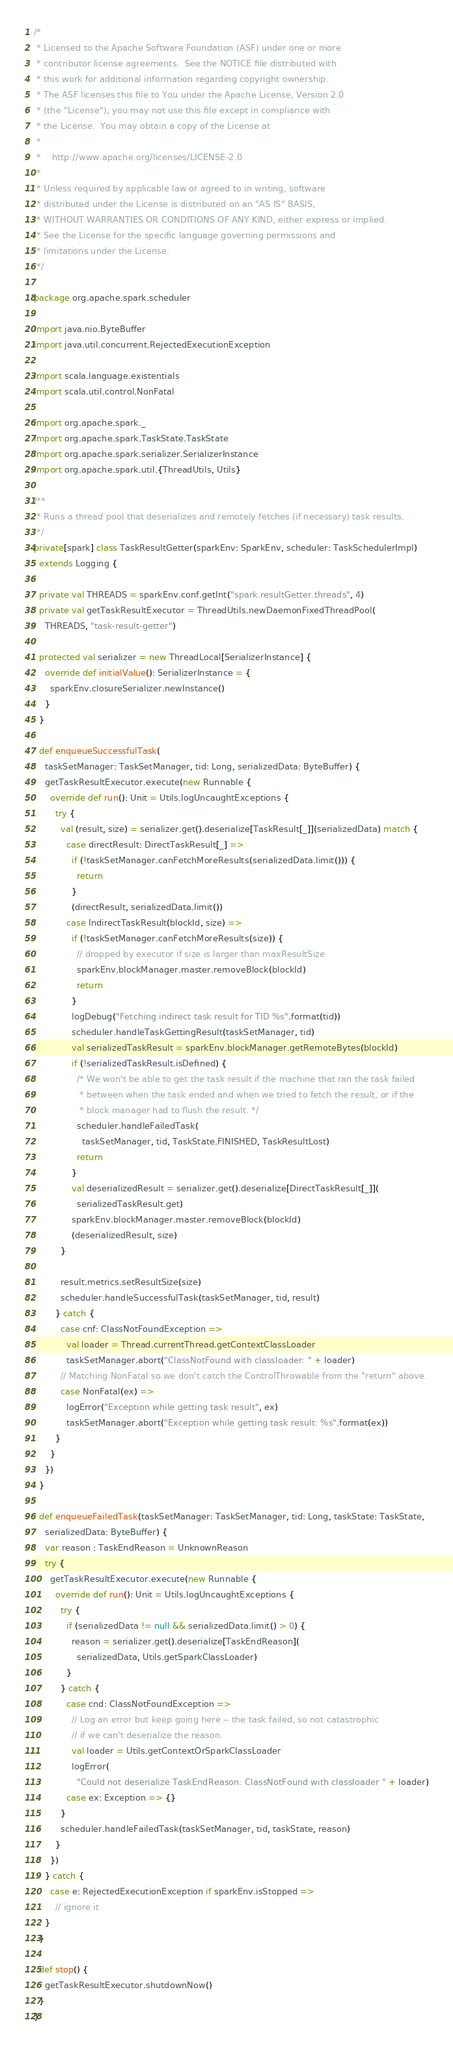Convert code to text. <code><loc_0><loc_0><loc_500><loc_500><_Scala_>/*
 * Licensed to the Apache Software Foundation (ASF) under one or more
 * contributor license agreements.  See the NOTICE file distributed with
 * this work for additional information regarding copyright ownership.
 * The ASF licenses this file to You under the Apache License, Version 2.0
 * (the "License"); you may not use this file except in compliance with
 * the License.  You may obtain a copy of the License at
 *
 *    http://www.apache.org/licenses/LICENSE-2.0
 *
 * Unless required by applicable law or agreed to in writing, software
 * distributed under the License is distributed on an "AS IS" BASIS,
 * WITHOUT WARRANTIES OR CONDITIONS OF ANY KIND, either express or implied.
 * See the License for the specific language governing permissions and
 * limitations under the License.
 */

package org.apache.spark.scheduler

import java.nio.ByteBuffer
import java.util.concurrent.RejectedExecutionException

import scala.language.existentials
import scala.util.control.NonFatal

import org.apache.spark._
import org.apache.spark.TaskState.TaskState
import org.apache.spark.serializer.SerializerInstance
import org.apache.spark.util.{ThreadUtils, Utils}

/**
 * Runs a thread pool that deserializes and remotely fetches (if necessary) task results.
 */
private[spark] class TaskResultGetter(sparkEnv: SparkEnv, scheduler: TaskSchedulerImpl)
  extends Logging {

  private val THREADS = sparkEnv.conf.getInt("spark.resultGetter.threads", 4)
  private val getTaskResultExecutor = ThreadUtils.newDaemonFixedThreadPool(
    THREADS, "task-result-getter")

  protected val serializer = new ThreadLocal[SerializerInstance] {
    override def initialValue(): SerializerInstance = {
      sparkEnv.closureSerializer.newInstance()
    }
  }

  def enqueueSuccessfulTask(
    taskSetManager: TaskSetManager, tid: Long, serializedData: ByteBuffer) {
    getTaskResultExecutor.execute(new Runnable {
      override def run(): Unit = Utils.logUncaughtExceptions {
        try {
          val (result, size) = serializer.get().deserialize[TaskResult[_]](serializedData) match {
            case directResult: DirectTaskResult[_] =>
              if (!taskSetManager.canFetchMoreResults(serializedData.limit())) {
                return
              }
              (directResult, serializedData.limit())
            case IndirectTaskResult(blockId, size) =>
              if (!taskSetManager.canFetchMoreResults(size)) {
                // dropped by executor if size is larger than maxResultSize
                sparkEnv.blockManager.master.removeBlock(blockId)
                return
              }
              logDebug("Fetching indirect task result for TID %s".format(tid))
              scheduler.handleTaskGettingResult(taskSetManager, tid)
              val serializedTaskResult = sparkEnv.blockManager.getRemoteBytes(blockId)
              if (!serializedTaskResult.isDefined) {
                /* We won't be able to get the task result if the machine that ran the task failed
                 * between when the task ended and when we tried to fetch the result, or if the
                 * block manager had to flush the result. */
                scheduler.handleFailedTask(
                  taskSetManager, tid, TaskState.FINISHED, TaskResultLost)
                return
              }
              val deserializedResult = serializer.get().deserialize[DirectTaskResult[_]](
                serializedTaskResult.get)
              sparkEnv.blockManager.master.removeBlock(blockId)
              (deserializedResult, size)
          }

          result.metrics.setResultSize(size)
          scheduler.handleSuccessfulTask(taskSetManager, tid, result)
        } catch {
          case cnf: ClassNotFoundException =>
            val loader = Thread.currentThread.getContextClassLoader
            taskSetManager.abort("ClassNotFound with classloader: " + loader)
          // Matching NonFatal so we don't catch the ControlThrowable from the "return" above.
          case NonFatal(ex) =>
            logError("Exception while getting task result", ex)
            taskSetManager.abort("Exception while getting task result: %s".format(ex))
        }
      }
    })
  }

  def enqueueFailedTask(taskSetManager: TaskSetManager, tid: Long, taskState: TaskState,
    serializedData: ByteBuffer) {
    var reason : TaskEndReason = UnknownReason
    try {
      getTaskResultExecutor.execute(new Runnable {
        override def run(): Unit = Utils.logUncaughtExceptions {
          try {
            if (serializedData != null && serializedData.limit() > 0) {
              reason = serializer.get().deserialize[TaskEndReason](
                serializedData, Utils.getSparkClassLoader)
            }
          } catch {
            case cnd: ClassNotFoundException =>
              // Log an error but keep going here -- the task failed, so not catastrophic
              // if we can't deserialize the reason.
              val loader = Utils.getContextOrSparkClassLoader
              logError(
                "Could not deserialize TaskEndReason: ClassNotFound with classloader " + loader)
            case ex: Exception => {}
          }
          scheduler.handleFailedTask(taskSetManager, tid, taskState, reason)
        }
      })
    } catch {
      case e: RejectedExecutionException if sparkEnv.isStopped =>
        // ignore it
    }
  }

  def stop() {
    getTaskResultExecutor.shutdownNow()
  }
}
</code> 